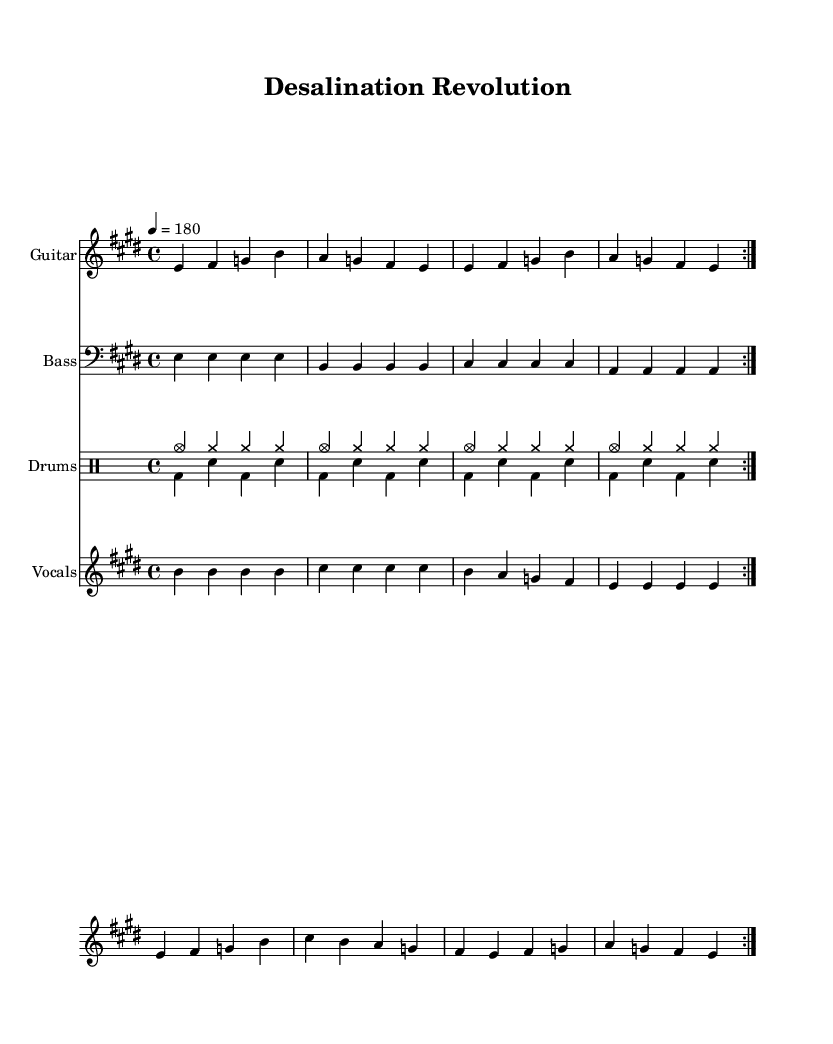What is the key signature of this music? The key signature is E major, which has four sharps: F#, C#, G#, and D#. This is indicated by the sharp symbols placed after the clef at the beginning of the staff.
Answer: E major What is the time signature of this music? The time signature is 4/4, which means there are four beats per measure and the quarter note gets one beat. This can be identified by the "4/4" indication after the clef.
Answer: 4/4 What is the tempo marking for this track? The tempo marking states "4 = 180," which means there are 180 beats per minute, with each beat corresponding to a quarter note. This is indicated prominently at the beginning of the music.
Answer: 180 How many times is the electric guitar section repeated? The electric guitar section is marked with "\repeat volta 2," indicating that this section should be played twice. This instruction is present at the beginning of the guitar staff.
Answer: 2 What is the main theme of the lyrics in the verse? The lyrics focus on "salty water" as a curse to the planet and the potential of innovation to address this issue. The lyrics are written in a straightforward manner beneath the vocal melody.
Answer: Innovation What is the rhythmic feel of the drums in the track? The drums feature a combination of cymbals and bass drum patterns that create a driving rhythm typical of punk music—a fast and energetic feel. This is inferred from the consistent use of strong downbeats and syncopation in the drum sections.
Answer: Fast-paced What is a prominent chord used in the guitar part? The prominent chords in the electric guitar part include E major, as inferred from the repeated use of E, G#, and B in the melody, which constitute the E major chord. This can be deduced from the played notes in the electric guitar staff.
Answer: E major 